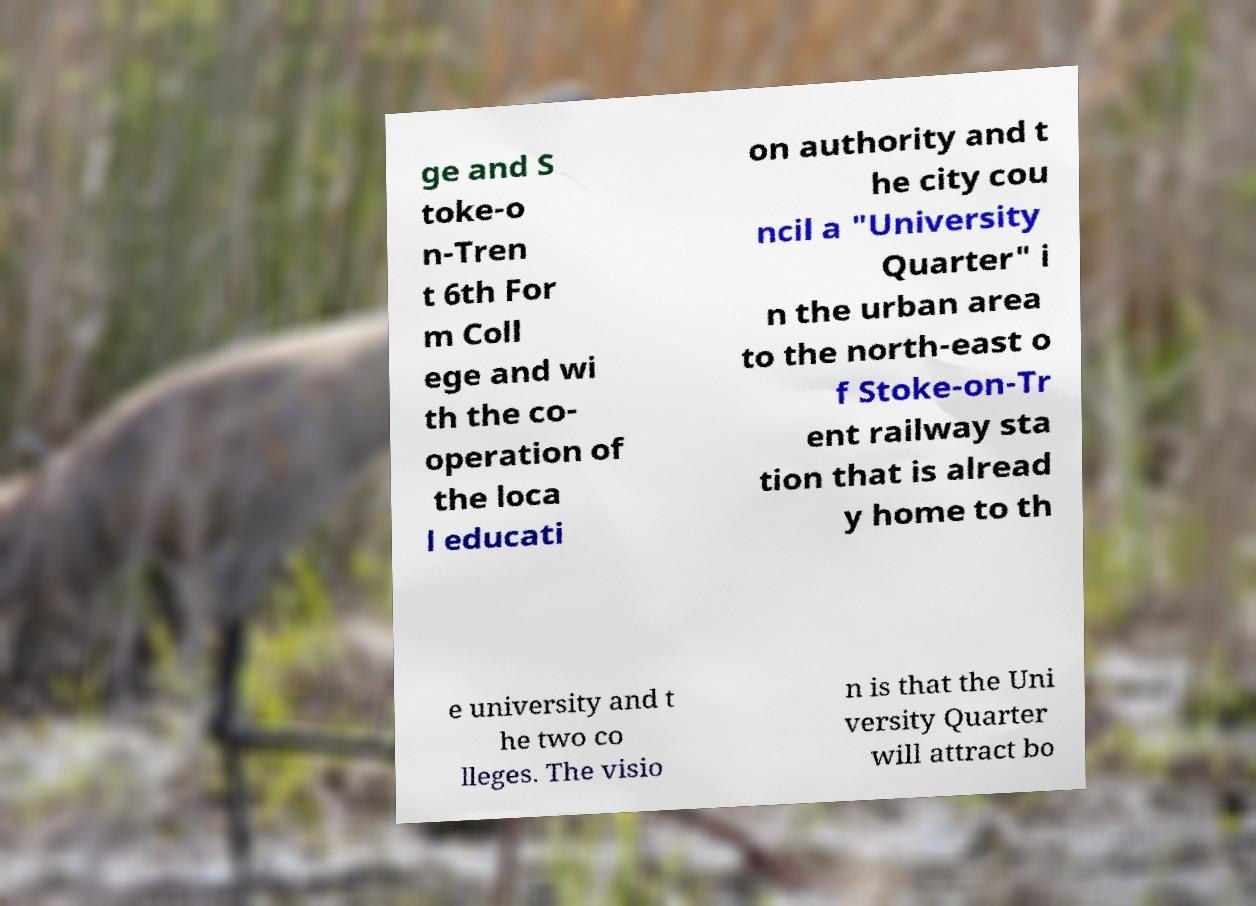What messages or text are displayed in this image? I need them in a readable, typed format. ge and S toke-o n-Tren t 6th For m Coll ege and wi th the co- operation of the loca l educati on authority and t he city cou ncil a "University Quarter" i n the urban area to the north-east o f Stoke-on-Tr ent railway sta tion that is alread y home to th e university and t he two co lleges. The visio n is that the Uni versity Quarter will attract bo 